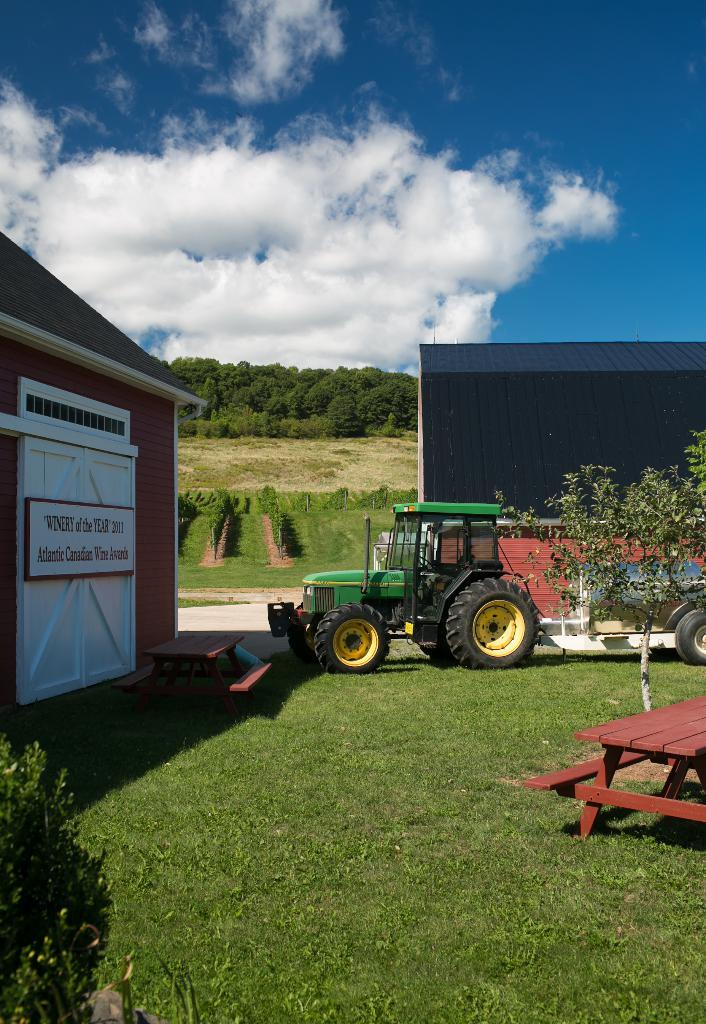What is located on the grass in the image? There is a vehicle on the grass in the image. What type of vegetation can be seen in the image? There is a plant and trees in the image. What type of structure is present in the image? There is a house in the image. What is visible in the background of the image? The background of the image includes a sky with heavy clouds. Can you see the elbow of the person driving the vehicle in the image? There is no person or elbow visible in the image; it only shows a vehicle on the grass. What type of ear is present on the plant in the image? There is no ear present in the image; it features a plant and trees, but not an ear. 